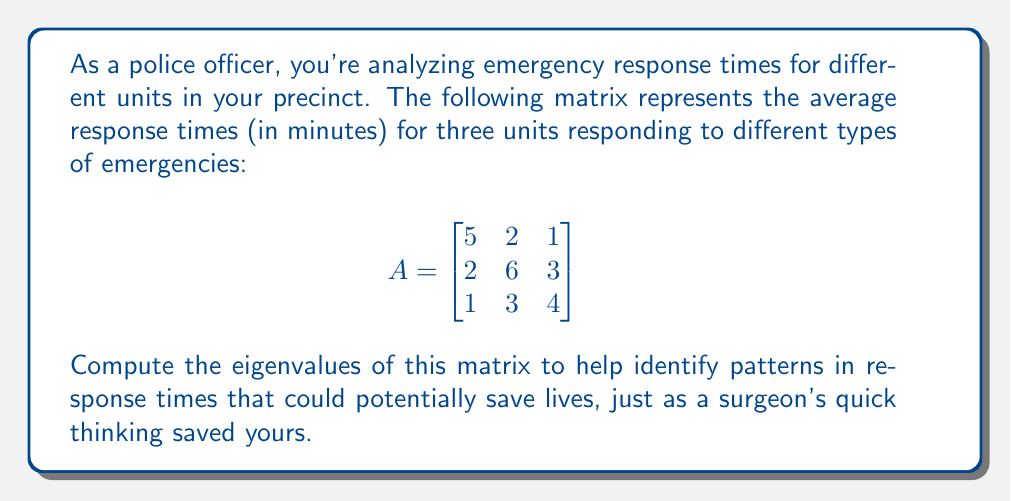What is the answer to this math problem? To find the eigenvalues of matrix $A$, we need to solve the characteristic equation:

$det(A - \lambda I) = 0$

where $\lambda$ represents the eigenvalues and $I$ is the 3x3 identity matrix.

Step 1: Set up the characteristic equation:
$$det\begin{pmatrix}
5-\lambda & 2 & 1 \\
2 & 6-\lambda & 3 \\
1 & 3 & 4-\lambda
\end{pmatrix} = 0$$

Step 2: Expand the determinant:
$$(5-\lambda)[(6-\lambda)(4-\lambda)-9] - 2[2(4-\lambda)-3] + 1[2(3)-3(6-\lambda)] = 0$$

Step 3: Simplify:
$$(5-\lambda)[(24-10\lambda+\lambda^2)-9] - 2[8-2\lambda-3] + 1[6-18+3\lambda] = 0$$
$$(5-\lambda)(15-10\lambda+\lambda^2) - 2(5-2\lambda) + (3\lambda-12) = 0$$

Step 4: Expand further:
$$75-50\lambda+5\lambda^2-15\lambda+10\lambda^2-\lambda^3 - 10+4\lambda + 3\lambda-12 = 0$$

Step 5: Collect terms:
$$-\lambda^3 + 15\lambda^2 - 58\lambda + 53 = 0$$

Step 6: This is a cubic equation. We can solve it using the rational root theorem or a computer algebra system. The roots are:

$\lambda_1 = 1$
$\lambda_2 = 7$
$\lambda_3 = 7$

These are the eigenvalues of the matrix $A$.
Answer: $\lambda_1 = 1$, $\lambda_2 = \lambda_3 = 7$ 